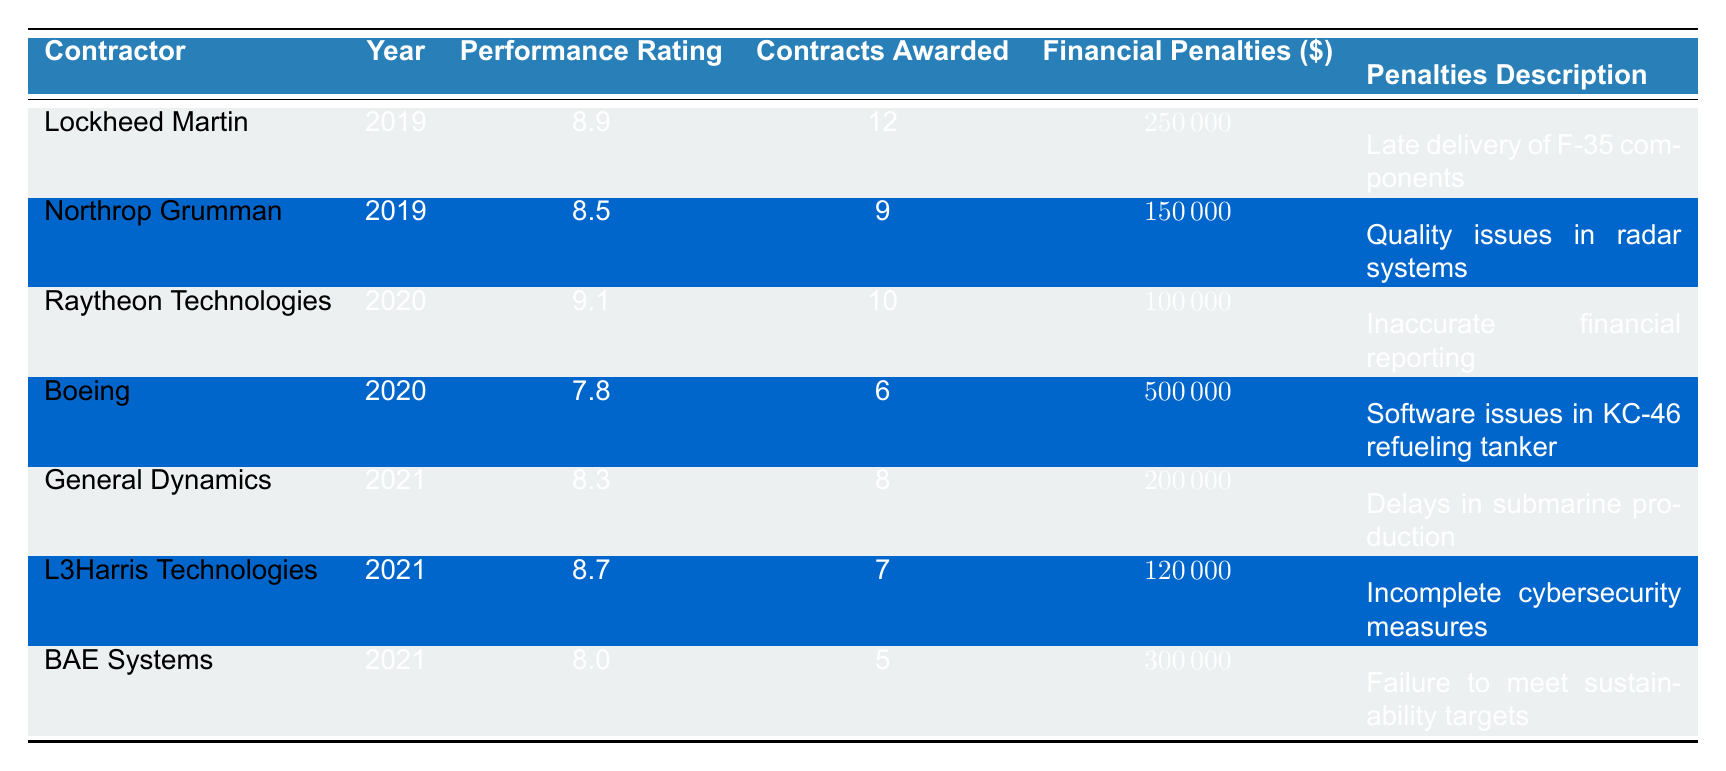What financial penalties were assessed to Boeing in 2020? According to the table, Boeing was assessed financial penalties of 500000 in 2020 due to software issues in the KC-46 refueling tanker.
Answer: 500000 Which contractor had the highest performance rating in 2019? From the table, Lockheed Martin had the highest performance rating of 8.9 in 2019, higher than Northrop Grumman's 8.5.
Answer: Lockheed Martin What is the total amount of financial penalties assessed from 2019 to 2021? The financial penalties per year are: 2019: 250000 + 150000 = 400000; 2020: 100000 + 500000 = 600000; 2021: 200000 + 120000 + 300000 = 620000. The total is 400000 + 600000 + 620000 = 1620000.
Answer: 1620000 Did any contractor receive penalties for delays in production in 2021? The data shows that General Dynamics received penalties for delays in submarine production in 2021.
Answer: Yes Which contractor had the lowest performance rating in 2021 and what were the financial penalties? In 2021, BAE Systems had the lowest performance rating of 8.0 and was assessed financial penalties of 300000 for failing to meet sustainability targets.
Answer: BAE Systems, 300000 What is the difference in performance ratings between Raytheon Technologies and Boeing in 2020? Raytheon Technologies had a performance rating of 9.1 in 2020, while Boeing had a rating of 7.8. The difference is 9.1 - 7.8 = 1.3.
Answer: 1.3 How many contracts were awarded to L3Harris Technologies in 2021? The table indicates that L3Harris Technologies was awarded 7 contracts in 2021.
Answer: 7 What specific issue led to financial penalties for Northrop Grumman in 2019? The table states that Northrop Grumman faced financial penalties for quality issues in radar systems in 2019.
Answer: Quality issues in radar systems 